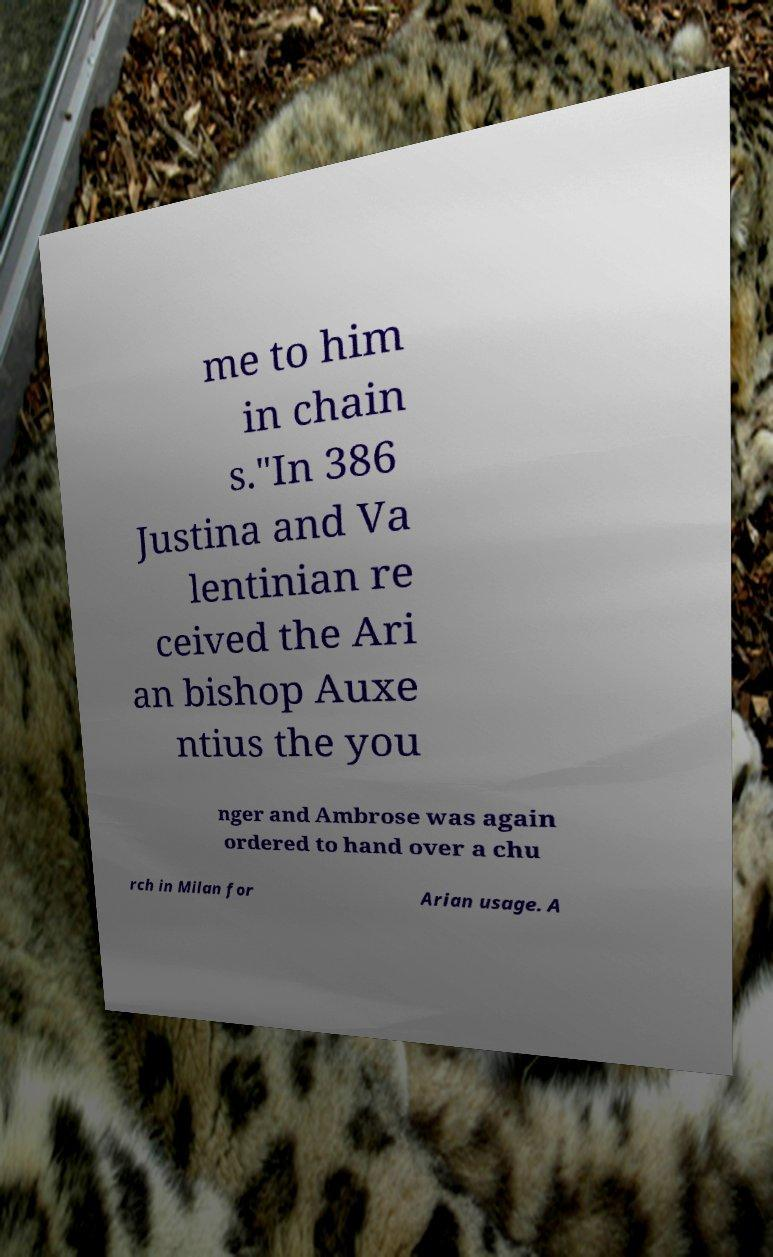There's text embedded in this image that I need extracted. Can you transcribe it verbatim? me to him in chain s."In 386 Justina and Va lentinian re ceived the Ari an bishop Auxe ntius the you nger and Ambrose was again ordered to hand over a chu rch in Milan for Arian usage. A 